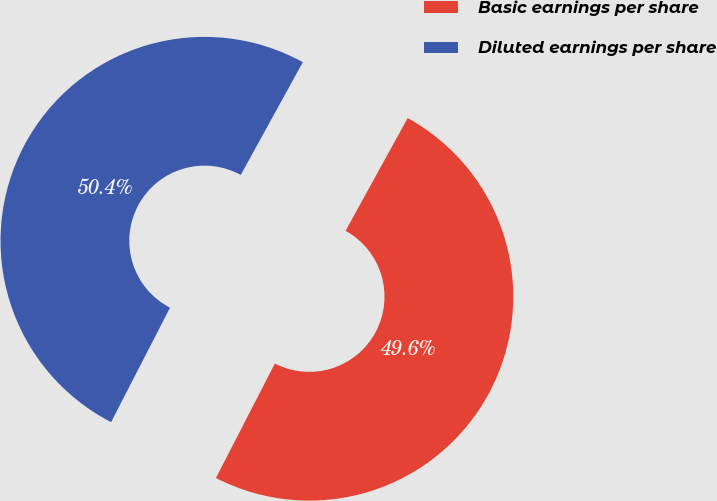Convert chart. <chart><loc_0><loc_0><loc_500><loc_500><pie_chart><fcel>Basic earnings per share<fcel>Diluted earnings per share<nl><fcel>49.56%<fcel>50.44%<nl></chart> 